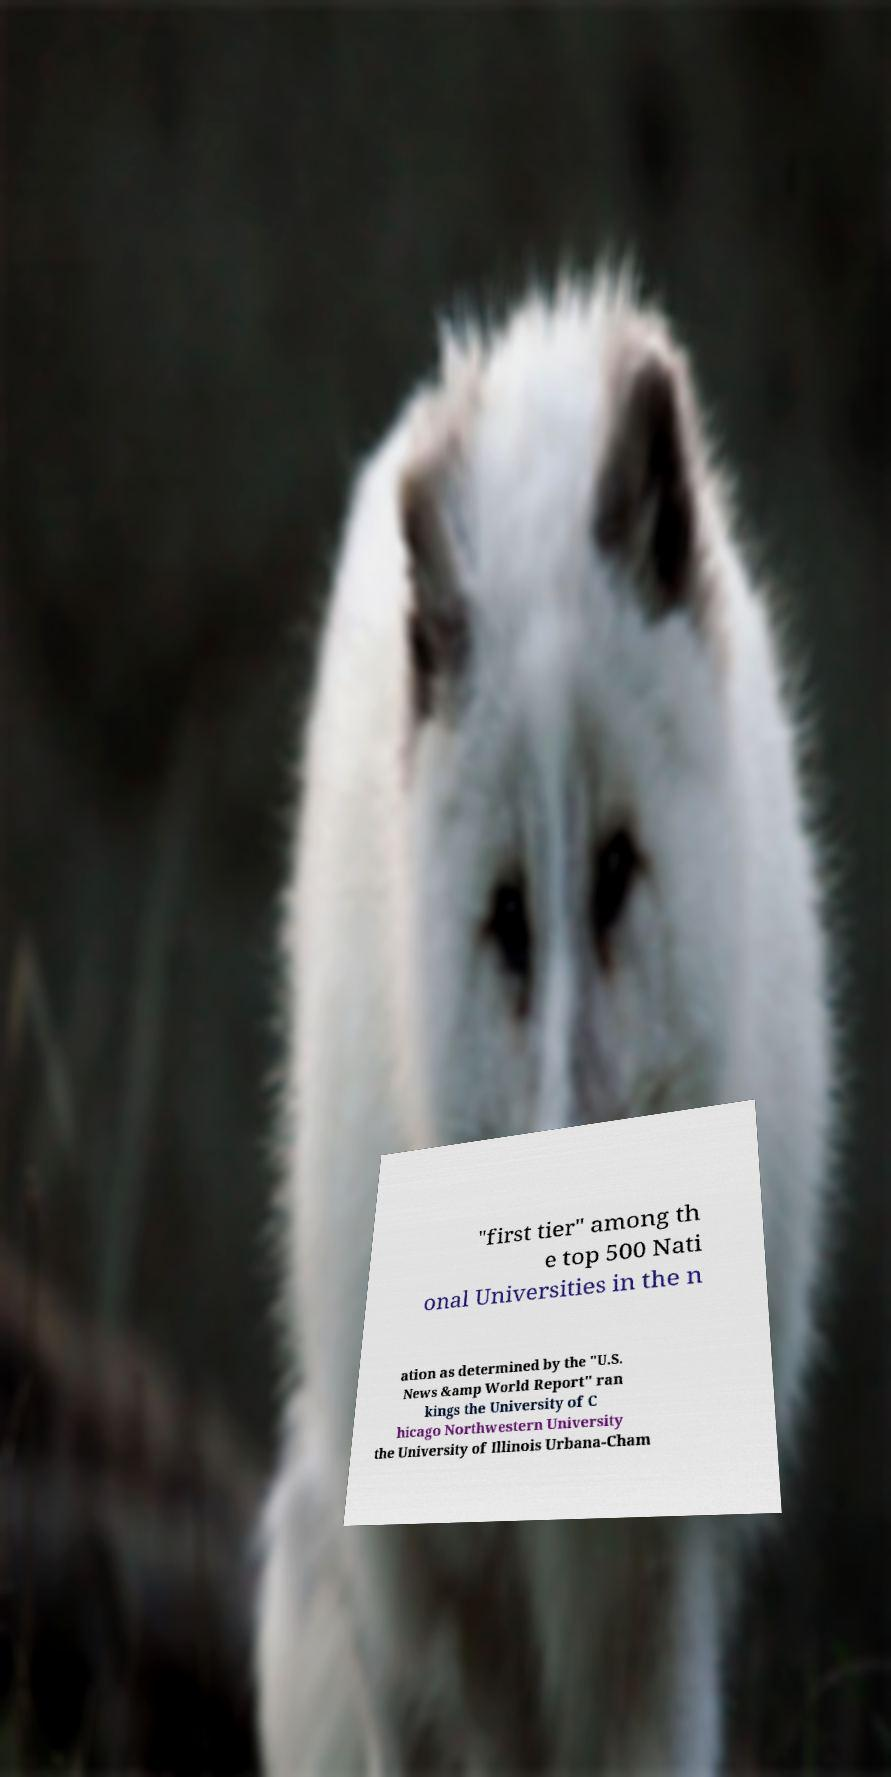Could you extract and type out the text from this image? "first tier" among th e top 500 Nati onal Universities in the n ation as determined by the "U.S. News &amp World Report" ran kings the University of C hicago Northwestern University the University of Illinois Urbana-Cham 